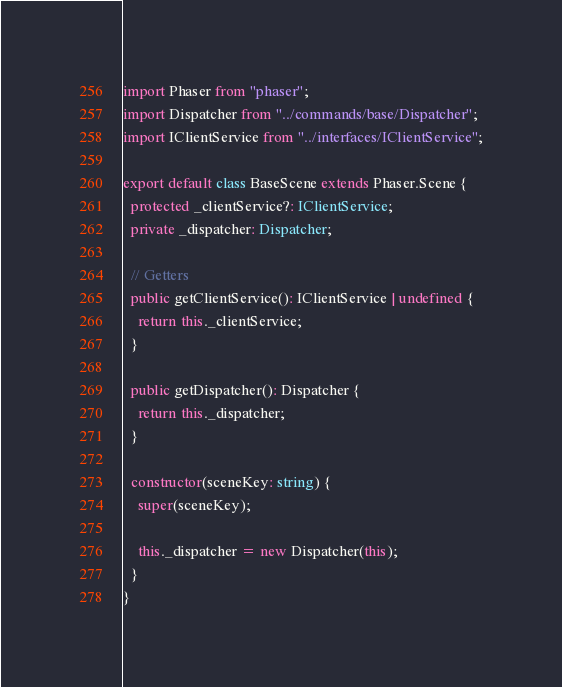Convert code to text. <code><loc_0><loc_0><loc_500><loc_500><_TypeScript_>import Phaser from "phaser";
import Dispatcher from "../commands/base/Dispatcher";
import IClientService from "../interfaces/IClientService";

export default class BaseScene extends Phaser.Scene {
  protected _clientService?: IClientService;
  private _dispatcher: Dispatcher;

  // Getters
  public getClientService(): IClientService | undefined {
    return this._clientService;
  }

  public getDispatcher(): Dispatcher {
    return this._dispatcher;
  }

  constructor(sceneKey: string) {
    super(sceneKey);

    this._dispatcher = new Dispatcher(this);
  }
}
</code> 